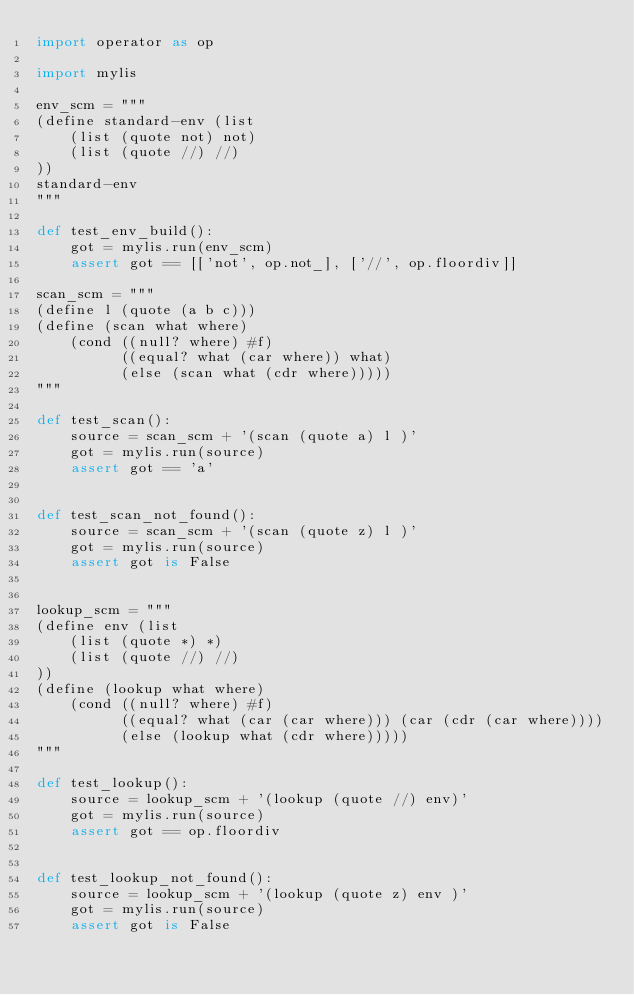Convert code to text. <code><loc_0><loc_0><loc_500><loc_500><_Python_>import operator as op

import mylis

env_scm = """
(define standard-env (list
    (list (quote not) not)
    (list (quote //) //)
))
standard-env
"""

def test_env_build():
    got = mylis.run(env_scm)
    assert got == [['not', op.not_], ['//', op.floordiv]]

scan_scm = """
(define l (quote (a b c)))
(define (scan what where)
    (cond ((null? where) #f)
          ((equal? what (car where)) what)
          (else (scan what (cdr where)))))
"""

def test_scan():
    source = scan_scm + '(scan (quote a) l )'
    got = mylis.run(source)
    assert got == 'a'


def test_scan_not_found():
    source = scan_scm + '(scan (quote z) l )'
    got = mylis.run(source)
    assert got is False


lookup_scm = """
(define env (list
    (list (quote *) *)
    (list (quote //) //)
))
(define (lookup what where)
    (cond ((null? where) #f)
          ((equal? what (car (car where))) (car (cdr (car where))))
          (else (lookup what (cdr where)))))
"""

def test_lookup():
    source = lookup_scm + '(lookup (quote //) env)'
    got = mylis.run(source)
    assert got == op.floordiv


def test_lookup_not_found():
    source = lookup_scm + '(lookup (quote z) env )'
    got = mylis.run(source)
    assert got is False
</code> 